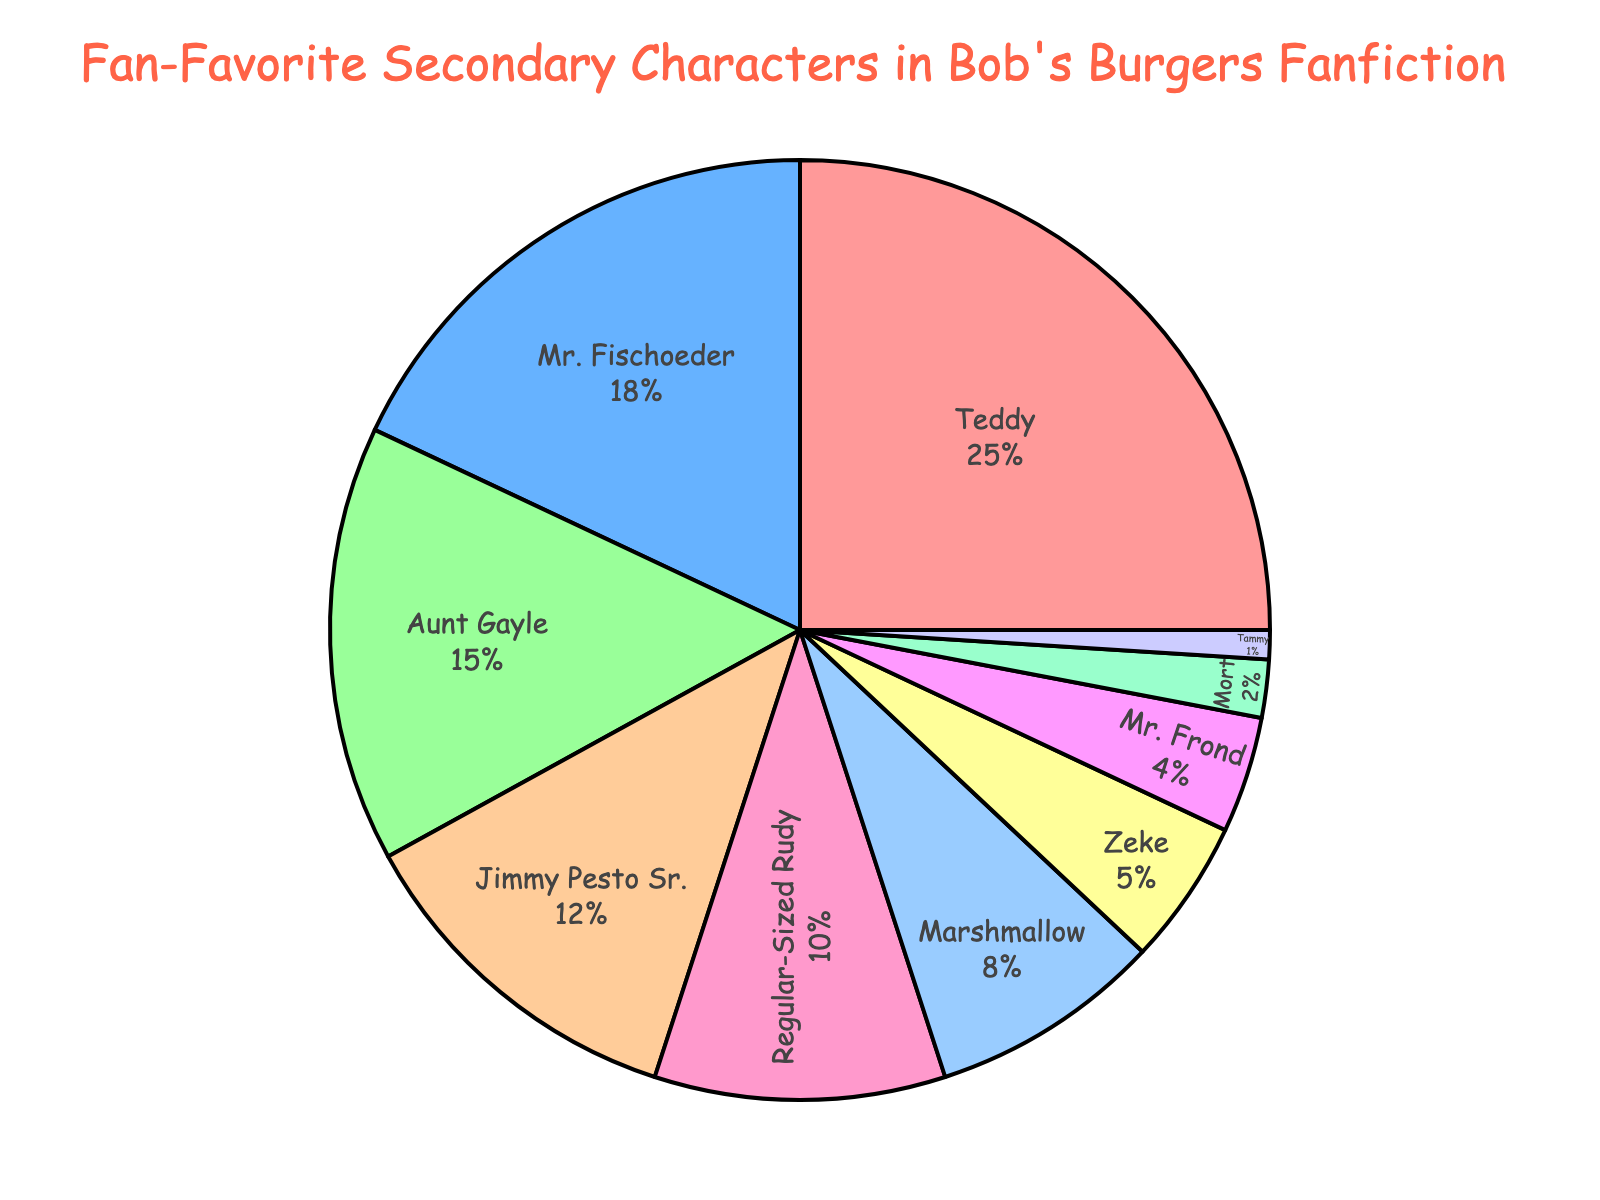What's the percentage of fan-favorite secondary characters combined for Teddy and Mr. Fischoeder? According to the figure, Teddy has 25% and Mr. Fischoeder has 18%. Adding these percentages together: 25 + 18 = 43%
Answer: 43% Which character has the smallest fan-favorite percentage? By looking at the pie chart, Tammy has the smallest slice corresponding to 1%.
Answer: Tammy Is the combined percentage of Marshmallow and Zeke greater than Aunt Gayle's percentage? Marshmallow has 8% and Zeke has 5%. Adding these together gives 8 + 5 = 13%. Aunt Gayle's percentage is 15%. So, 13% is less than 15%.
Answer: No Which character has one-fourth the percentage of Teddy? Teddy has 25%. One-fourth of 25% is 25/4 = 6.25%. Looking at the figure, no character has exactly 6.25%, but close to it, Zeke has 5%.
Answer: Zeke Name all characters that have a percentage greater than or equal to 10%. From the pie chart, we can see that Teddy (25%), Mr. Fischoeder (18%), Aunt Gayle (15%), Jimmy Pesto Sr. (12%), and Regular-Sized Rudy (10%) have percentages greater than or equal to 10%.
Answer: Teddy, Mr. Fischoeder, Aunt Gayle, Jimmy Pesto Sr., Regular-Sized Rudy What percentage of fan-favorite secondary characters does Mort have? By referring to the pie chart, Mort has a 2% fan-favorite percentage.
Answer: 2% Who are the characters with percentages less than 10%, but more than 1%? The characters within this range according to the pie chart are Marshmallow (8%), Zeke (5%), and Mr. Frond (4%).
Answer: Marshmallow, Zeke, Mr. Frond Compare the percentages of Jimmy Pesto Sr. and Regular-Sized Rudy. Who has a higher percentage, and by how much? Jimmy Pesto Sr. has 12% and Regular-Sized Rudy has 10%. The difference is 12 - 10 = 2%. Jimmy Pesto Sr. has a higher percentage by 2%.
Answer: Jimmy Pesto Sr., 2% 